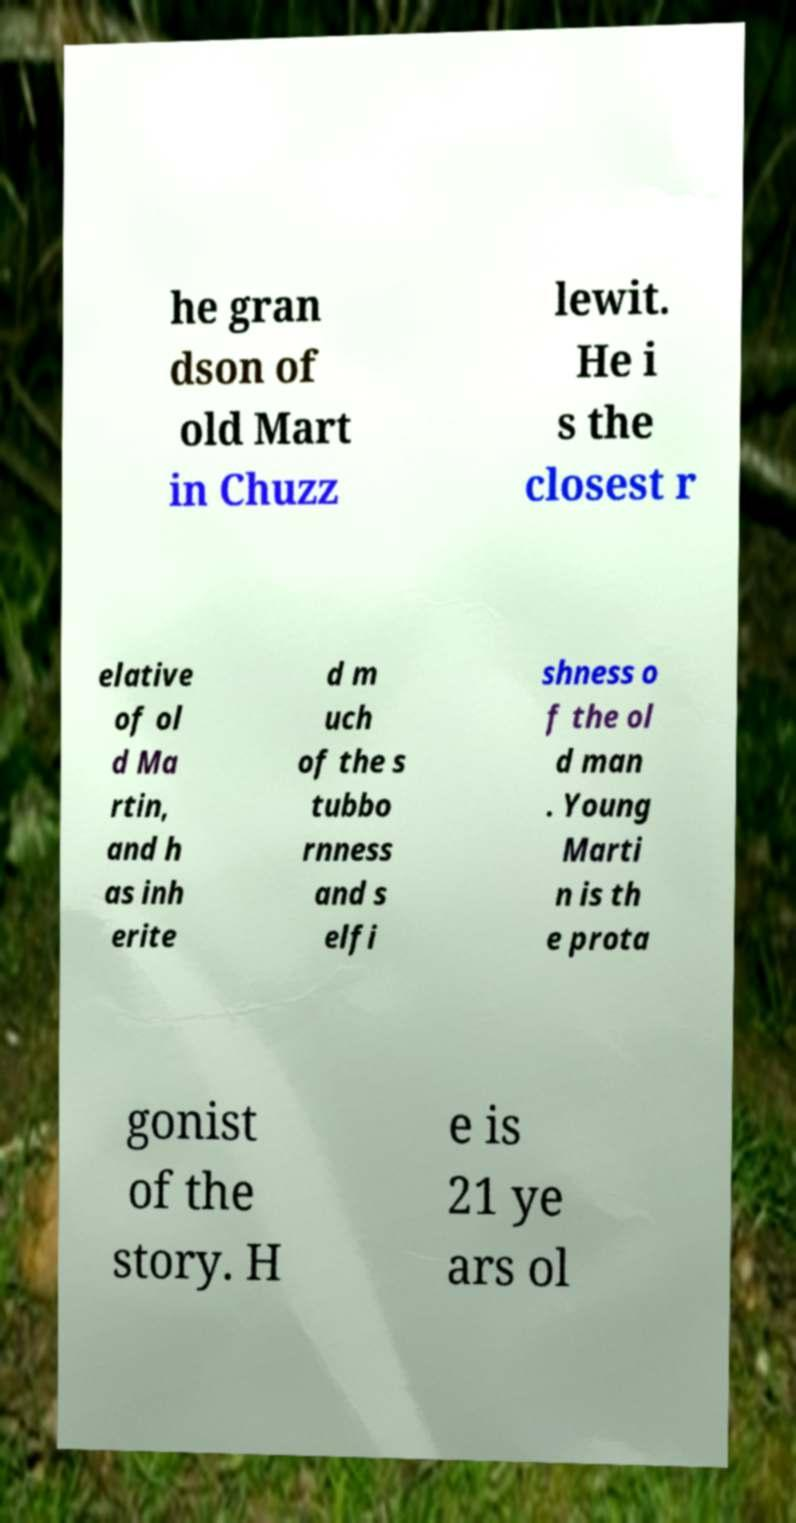There's text embedded in this image that I need extracted. Can you transcribe it verbatim? he gran dson of old Mart in Chuzz lewit. He i s the closest r elative of ol d Ma rtin, and h as inh erite d m uch of the s tubbo rnness and s elfi shness o f the ol d man . Young Marti n is th e prota gonist of the story. H e is 21 ye ars ol 